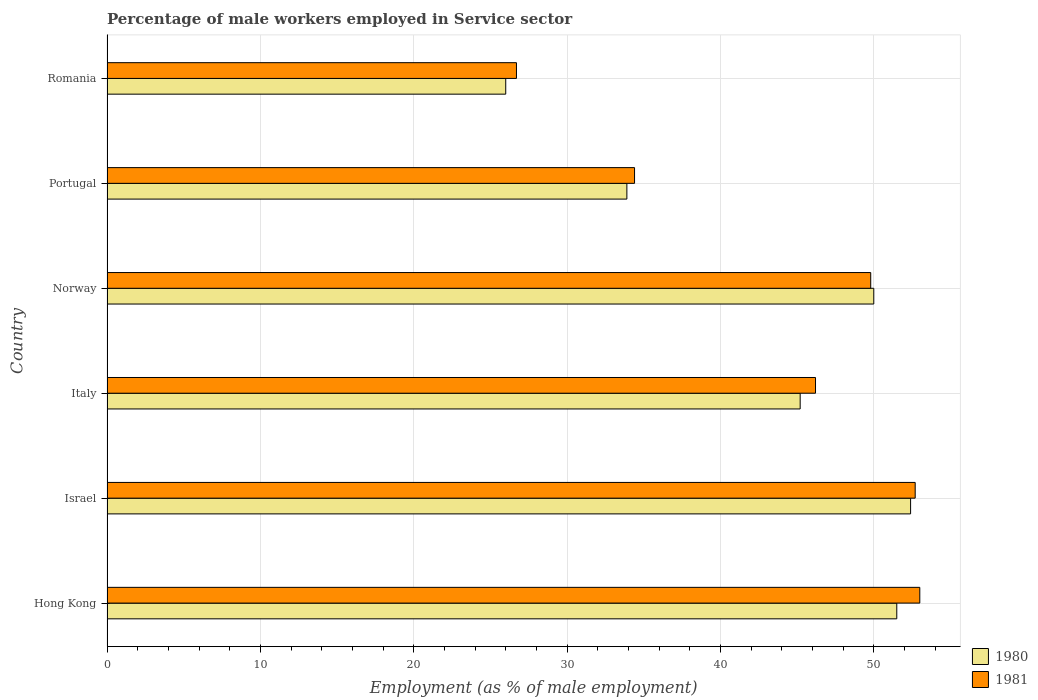How many different coloured bars are there?
Keep it short and to the point. 2. How many groups of bars are there?
Give a very brief answer. 6. Are the number of bars on each tick of the Y-axis equal?
Provide a succinct answer. Yes. How many bars are there on the 2nd tick from the top?
Make the answer very short. 2. What is the percentage of male workers employed in Service sector in 1980 in Italy?
Make the answer very short. 45.2. Across all countries, what is the minimum percentage of male workers employed in Service sector in 1980?
Provide a short and direct response. 26. In which country was the percentage of male workers employed in Service sector in 1981 maximum?
Provide a succinct answer. Hong Kong. In which country was the percentage of male workers employed in Service sector in 1981 minimum?
Provide a short and direct response. Romania. What is the total percentage of male workers employed in Service sector in 1980 in the graph?
Offer a terse response. 259. What is the difference between the percentage of male workers employed in Service sector in 1980 in Italy and that in Norway?
Give a very brief answer. -4.8. What is the difference between the percentage of male workers employed in Service sector in 1981 in Hong Kong and the percentage of male workers employed in Service sector in 1980 in Romania?
Your response must be concise. 27. What is the average percentage of male workers employed in Service sector in 1980 per country?
Offer a terse response. 43.17. What is the difference between the percentage of male workers employed in Service sector in 1981 and percentage of male workers employed in Service sector in 1980 in Norway?
Your answer should be very brief. -0.2. In how many countries, is the percentage of male workers employed in Service sector in 1980 greater than 10 %?
Offer a very short reply. 6. What is the ratio of the percentage of male workers employed in Service sector in 1980 in Norway to that in Portugal?
Ensure brevity in your answer.  1.47. Is the difference between the percentage of male workers employed in Service sector in 1981 in Israel and Norway greater than the difference between the percentage of male workers employed in Service sector in 1980 in Israel and Norway?
Provide a short and direct response. Yes. What is the difference between the highest and the second highest percentage of male workers employed in Service sector in 1981?
Keep it short and to the point. 0.3. What is the difference between the highest and the lowest percentage of male workers employed in Service sector in 1981?
Ensure brevity in your answer.  26.3. In how many countries, is the percentage of male workers employed in Service sector in 1980 greater than the average percentage of male workers employed in Service sector in 1980 taken over all countries?
Your answer should be compact. 4. Is the sum of the percentage of male workers employed in Service sector in 1980 in Italy and Romania greater than the maximum percentage of male workers employed in Service sector in 1981 across all countries?
Your answer should be compact. Yes. What does the 2nd bar from the top in Hong Kong represents?
Ensure brevity in your answer.  1980. Are all the bars in the graph horizontal?
Offer a very short reply. Yes. How many countries are there in the graph?
Your answer should be compact. 6. What is the difference between two consecutive major ticks on the X-axis?
Give a very brief answer. 10. Does the graph contain any zero values?
Ensure brevity in your answer.  No. Does the graph contain grids?
Your response must be concise. Yes. How are the legend labels stacked?
Ensure brevity in your answer.  Vertical. What is the title of the graph?
Your response must be concise. Percentage of male workers employed in Service sector. Does "1994" appear as one of the legend labels in the graph?
Make the answer very short. No. What is the label or title of the X-axis?
Keep it short and to the point. Employment (as % of male employment). What is the label or title of the Y-axis?
Your answer should be compact. Country. What is the Employment (as % of male employment) of 1980 in Hong Kong?
Provide a short and direct response. 51.5. What is the Employment (as % of male employment) of 1981 in Hong Kong?
Make the answer very short. 53. What is the Employment (as % of male employment) in 1980 in Israel?
Keep it short and to the point. 52.4. What is the Employment (as % of male employment) in 1981 in Israel?
Make the answer very short. 52.7. What is the Employment (as % of male employment) of 1980 in Italy?
Offer a terse response. 45.2. What is the Employment (as % of male employment) of 1981 in Italy?
Your answer should be very brief. 46.2. What is the Employment (as % of male employment) in 1981 in Norway?
Offer a very short reply. 49.8. What is the Employment (as % of male employment) in 1980 in Portugal?
Make the answer very short. 33.9. What is the Employment (as % of male employment) of 1981 in Portugal?
Keep it short and to the point. 34.4. What is the Employment (as % of male employment) of 1981 in Romania?
Provide a short and direct response. 26.7. Across all countries, what is the maximum Employment (as % of male employment) of 1980?
Make the answer very short. 52.4. Across all countries, what is the maximum Employment (as % of male employment) in 1981?
Ensure brevity in your answer.  53. Across all countries, what is the minimum Employment (as % of male employment) of 1980?
Offer a terse response. 26. Across all countries, what is the minimum Employment (as % of male employment) of 1981?
Your answer should be very brief. 26.7. What is the total Employment (as % of male employment) in 1980 in the graph?
Make the answer very short. 259. What is the total Employment (as % of male employment) of 1981 in the graph?
Ensure brevity in your answer.  262.8. What is the difference between the Employment (as % of male employment) in 1981 in Hong Kong and that in Israel?
Provide a succinct answer. 0.3. What is the difference between the Employment (as % of male employment) of 1981 in Hong Kong and that in Italy?
Keep it short and to the point. 6.8. What is the difference between the Employment (as % of male employment) of 1981 in Hong Kong and that in Norway?
Offer a terse response. 3.2. What is the difference between the Employment (as % of male employment) of 1980 in Hong Kong and that in Portugal?
Provide a short and direct response. 17.6. What is the difference between the Employment (as % of male employment) of 1981 in Hong Kong and that in Portugal?
Ensure brevity in your answer.  18.6. What is the difference between the Employment (as % of male employment) of 1981 in Hong Kong and that in Romania?
Offer a very short reply. 26.3. What is the difference between the Employment (as % of male employment) of 1980 in Israel and that in Norway?
Give a very brief answer. 2.4. What is the difference between the Employment (as % of male employment) of 1980 in Israel and that in Portugal?
Ensure brevity in your answer.  18.5. What is the difference between the Employment (as % of male employment) of 1981 in Israel and that in Portugal?
Provide a short and direct response. 18.3. What is the difference between the Employment (as % of male employment) of 1980 in Israel and that in Romania?
Provide a succinct answer. 26.4. What is the difference between the Employment (as % of male employment) of 1981 in Israel and that in Romania?
Your response must be concise. 26. What is the difference between the Employment (as % of male employment) of 1980 in Italy and that in Norway?
Ensure brevity in your answer.  -4.8. What is the difference between the Employment (as % of male employment) in 1981 in Italy and that in Norway?
Give a very brief answer. -3.6. What is the difference between the Employment (as % of male employment) in 1980 in Italy and that in Portugal?
Your answer should be very brief. 11.3. What is the difference between the Employment (as % of male employment) of 1981 in Italy and that in Romania?
Provide a succinct answer. 19.5. What is the difference between the Employment (as % of male employment) in 1981 in Norway and that in Portugal?
Your answer should be compact. 15.4. What is the difference between the Employment (as % of male employment) in 1980 in Norway and that in Romania?
Give a very brief answer. 24. What is the difference between the Employment (as % of male employment) in 1981 in Norway and that in Romania?
Make the answer very short. 23.1. What is the difference between the Employment (as % of male employment) of 1980 in Portugal and that in Romania?
Offer a terse response. 7.9. What is the difference between the Employment (as % of male employment) in 1981 in Portugal and that in Romania?
Offer a terse response. 7.7. What is the difference between the Employment (as % of male employment) of 1980 in Hong Kong and the Employment (as % of male employment) of 1981 in Israel?
Give a very brief answer. -1.2. What is the difference between the Employment (as % of male employment) of 1980 in Hong Kong and the Employment (as % of male employment) of 1981 in Norway?
Keep it short and to the point. 1.7. What is the difference between the Employment (as % of male employment) of 1980 in Hong Kong and the Employment (as % of male employment) of 1981 in Romania?
Your response must be concise. 24.8. What is the difference between the Employment (as % of male employment) in 1980 in Israel and the Employment (as % of male employment) in 1981 in Norway?
Ensure brevity in your answer.  2.6. What is the difference between the Employment (as % of male employment) in 1980 in Israel and the Employment (as % of male employment) in 1981 in Portugal?
Offer a terse response. 18. What is the difference between the Employment (as % of male employment) of 1980 in Israel and the Employment (as % of male employment) of 1981 in Romania?
Ensure brevity in your answer.  25.7. What is the difference between the Employment (as % of male employment) of 1980 in Italy and the Employment (as % of male employment) of 1981 in Norway?
Give a very brief answer. -4.6. What is the difference between the Employment (as % of male employment) in 1980 in Italy and the Employment (as % of male employment) in 1981 in Portugal?
Make the answer very short. 10.8. What is the difference between the Employment (as % of male employment) in 1980 in Norway and the Employment (as % of male employment) in 1981 in Romania?
Offer a terse response. 23.3. What is the average Employment (as % of male employment) of 1980 per country?
Your response must be concise. 43.17. What is the average Employment (as % of male employment) of 1981 per country?
Your response must be concise. 43.8. What is the difference between the Employment (as % of male employment) in 1980 and Employment (as % of male employment) in 1981 in Hong Kong?
Offer a very short reply. -1.5. What is the difference between the Employment (as % of male employment) in 1980 and Employment (as % of male employment) in 1981 in Israel?
Your response must be concise. -0.3. What is the difference between the Employment (as % of male employment) in 1980 and Employment (as % of male employment) in 1981 in Italy?
Make the answer very short. -1. What is the difference between the Employment (as % of male employment) of 1980 and Employment (as % of male employment) of 1981 in Norway?
Offer a very short reply. 0.2. What is the difference between the Employment (as % of male employment) of 1980 and Employment (as % of male employment) of 1981 in Portugal?
Your response must be concise. -0.5. What is the difference between the Employment (as % of male employment) of 1980 and Employment (as % of male employment) of 1981 in Romania?
Make the answer very short. -0.7. What is the ratio of the Employment (as % of male employment) of 1980 in Hong Kong to that in Israel?
Your answer should be compact. 0.98. What is the ratio of the Employment (as % of male employment) of 1981 in Hong Kong to that in Israel?
Your answer should be very brief. 1.01. What is the ratio of the Employment (as % of male employment) in 1980 in Hong Kong to that in Italy?
Give a very brief answer. 1.14. What is the ratio of the Employment (as % of male employment) in 1981 in Hong Kong to that in Italy?
Offer a terse response. 1.15. What is the ratio of the Employment (as % of male employment) in 1981 in Hong Kong to that in Norway?
Keep it short and to the point. 1.06. What is the ratio of the Employment (as % of male employment) in 1980 in Hong Kong to that in Portugal?
Provide a short and direct response. 1.52. What is the ratio of the Employment (as % of male employment) of 1981 in Hong Kong to that in Portugal?
Your response must be concise. 1.54. What is the ratio of the Employment (as % of male employment) of 1980 in Hong Kong to that in Romania?
Give a very brief answer. 1.98. What is the ratio of the Employment (as % of male employment) in 1981 in Hong Kong to that in Romania?
Your answer should be very brief. 1.99. What is the ratio of the Employment (as % of male employment) in 1980 in Israel to that in Italy?
Offer a terse response. 1.16. What is the ratio of the Employment (as % of male employment) of 1981 in Israel to that in Italy?
Make the answer very short. 1.14. What is the ratio of the Employment (as % of male employment) of 1980 in Israel to that in Norway?
Your answer should be compact. 1.05. What is the ratio of the Employment (as % of male employment) of 1981 in Israel to that in Norway?
Keep it short and to the point. 1.06. What is the ratio of the Employment (as % of male employment) of 1980 in Israel to that in Portugal?
Your answer should be very brief. 1.55. What is the ratio of the Employment (as % of male employment) of 1981 in Israel to that in Portugal?
Ensure brevity in your answer.  1.53. What is the ratio of the Employment (as % of male employment) in 1980 in Israel to that in Romania?
Your response must be concise. 2.02. What is the ratio of the Employment (as % of male employment) of 1981 in Israel to that in Romania?
Offer a terse response. 1.97. What is the ratio of the Employment (as % of male employment) of 1980 in Italy to that in Norway?
Give a very brief answer. 0.9. What is the ratio of the Employment (as % of male employment) of 1981 in Italy to that in Norway?
Your answer should be compact. 0.93. What is the ratio of the Employment (as % of male employment) in 1980 in Italy to that in Portugal?
Keep it short and to the point. 1.33. What is the ratio of the Employment (as % of male employment) in 1981 in Italy to that in Portugal?
Make the answer very short. 1.34. What is the ratio of the Employment (as % of male employment) in 1980 in Italy to that in Romania?
Offer a terse response. 1.74. What is the ratio of the Employment (as % of male employment) in 1981 in Italy to that in Romania?
Your answer should be compact. 1.73. What is the ratio of the Employment (as % of male employment) in 1980 in Norway to that in Portugal?
Your answer should be compact. 1.47. What is the ratio of the Employment (as % of male employment) of 1981 in Norway to that in Portugal?
Ensure brevity in your answer.  1.45. What is the ratio of the Employment (as % of male employment) of 1980 in Norway to that in Romania?
Your answer should be very brief. 1.92. What is the ratio of the Employment (as % of male employment) of 1981 in Norway to that in Romania?
Your answer should be compact. 1.87. What is the ratio of the Employment (as % of male employment) of 1980 in Portugal to that in Romania?
Provide a short and direct response. 1.3. What is the ratio of the Employment (as % of male employment) of 1981 in Portugal to that in Romania?
Offer a terse response. 1.29. What is the difference between the highest and the lowest Employment (as % of male employment) of 1980?
Provide a short and direct response. 26.4. What is the difference between the highest and the lowest Employment (as % of male employment) in 1981?
Offer a very short reply. 26.3. 